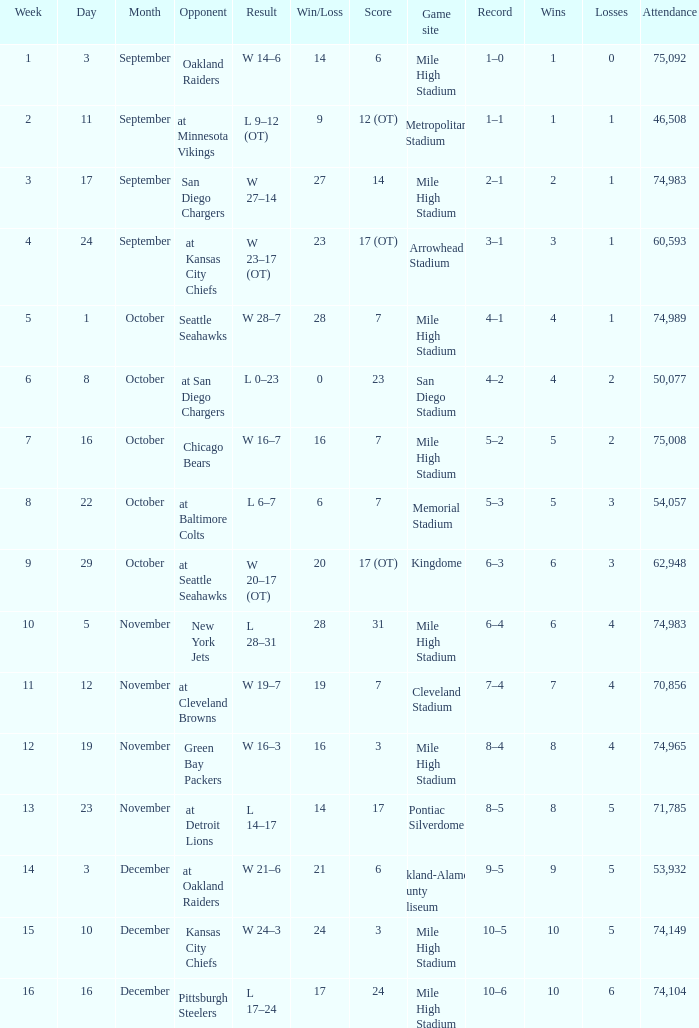On what date was the result w 28–7? October 1. 